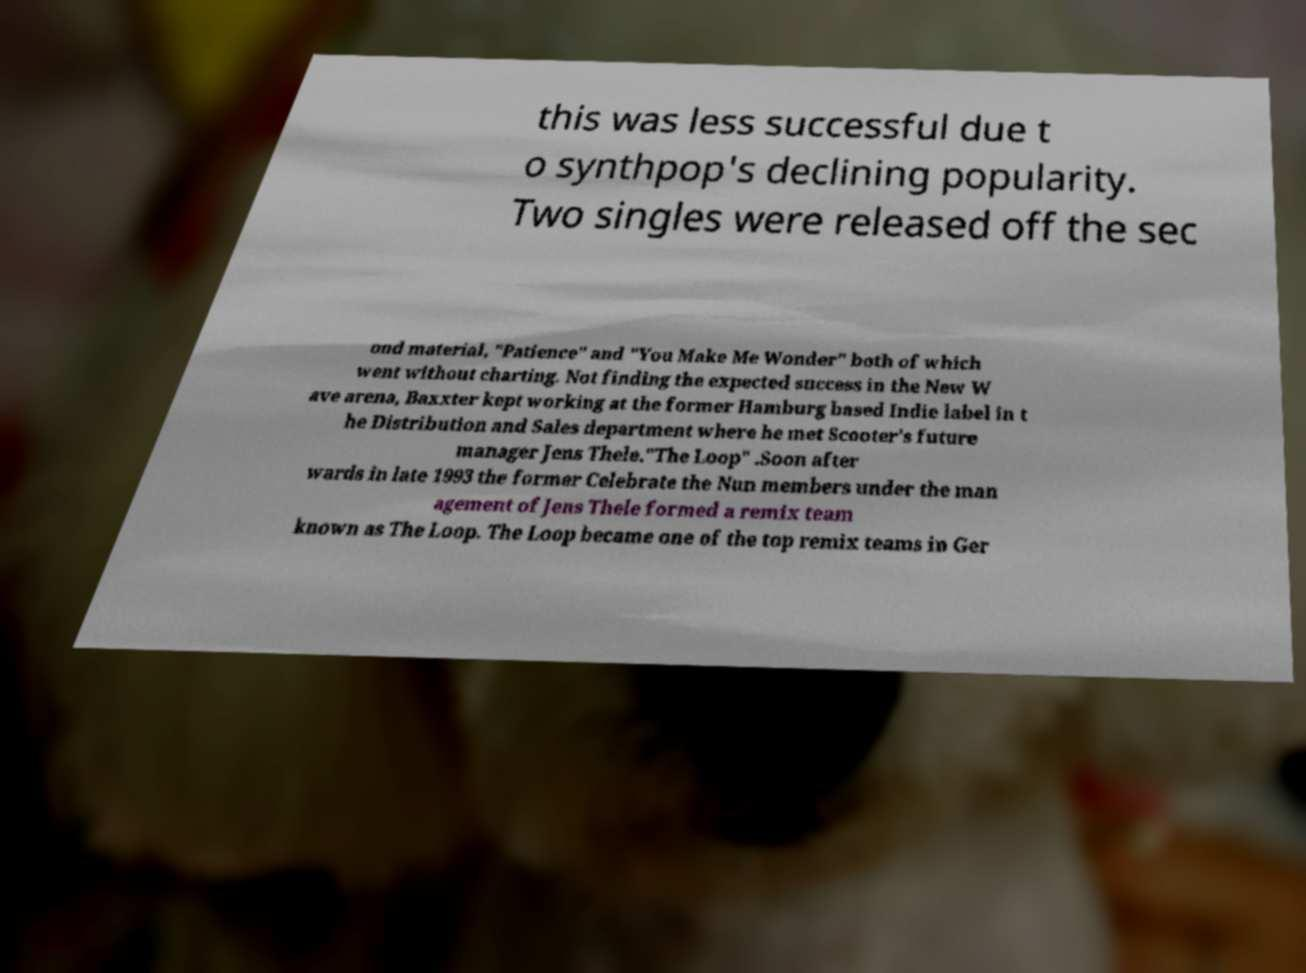I need the written content from this picture converted into text. Can you do that? this was less successful due t o synthpop's declining popularity. Two singles were released off the sec ond material, "Patience" and "You Make Me Wonder" both of which went without charting. Not finding the expected success in the New W ave arena, Baxxter kept working at the former Hamburg based Indie label in t he Distribution and Sales department where he met Scooter's future manager Jens Thele."The Loop" .Soon after wards in late 1993 the former Celebrate the Nun members under the man agement of Jens Thele formed a remix team known as The Loop. The Loop became one of the top remix teams in Ger 